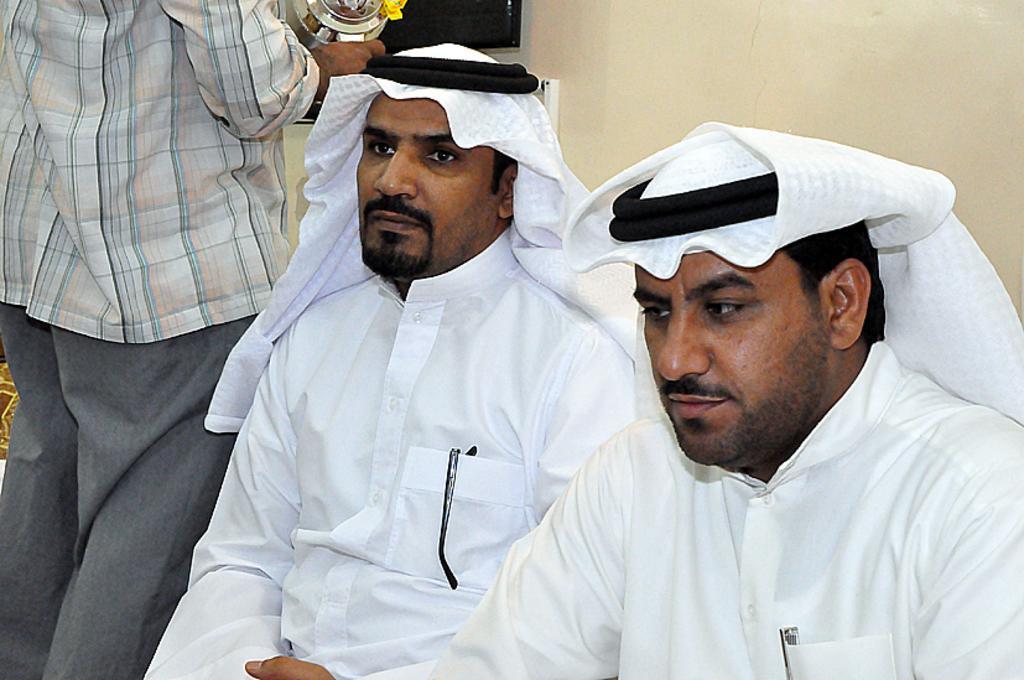How would you summarize this image in a sentence or two? Here I can see two men wearing white color dresses and headscarves and sitting facing towards the left side. Beside these people there is a man holding an object in hand and standing facing towards the back side. In the background there is a wall on which a monitor is attached. 